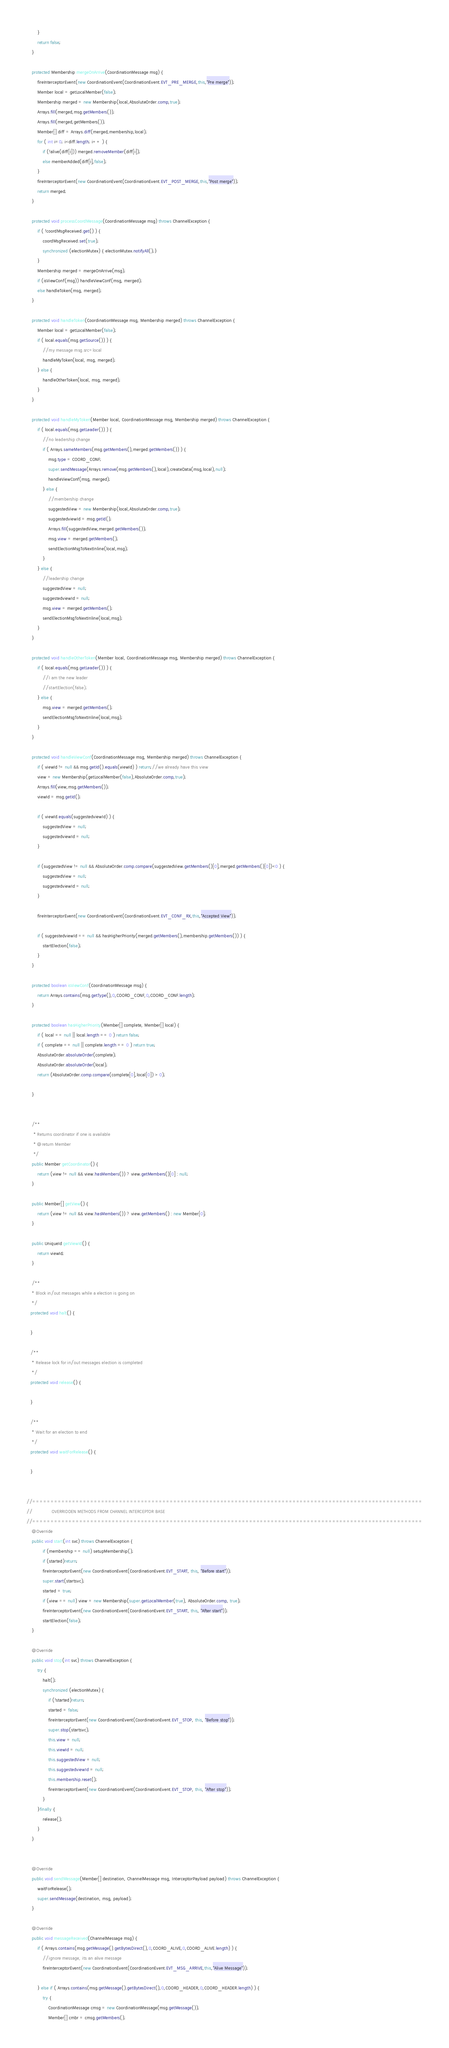<code> <loc_0><loc_0><loc_500><loc_500><_Java_>        }
        return false;
    }

    protected Membership mergeOnArrive(CoordinationMessage msg) {
        fireInterceptorEvent(new CoordinationEvent(CoordinationEvent.EVT_PRE_MERGE,this,"Pre merge"));
        Member local = getLocalMember(false);
        Membership merged = new Membership(local,AbsoluteOrder.comp,true);
        Arrays.fill(merged,msg.getMembers());
        Arrays.fill(merged,getMembers());
        Member[] diff = Arrays.diff(merged,membership,local);
        for ( int i=0; i<diff.length; i++ ) {
            if (!alive(diff[i])) merged.removeMember(diff[i]);
            else memberAdded(diff[i],false);
        }
        fireInterceptorEvent(new CoordinationEvent(CoordinationEvent.EVT_POST_MERGE,this,"Post merge"));
        return merged;
    }

    protected void processCoordMessage(CoordinationMessage msg) throws ChannelException {
        if ( !coordMsgReceived.get() ) {
            coordMsgReceived.set(true);
            synchronized (electionMutex) { electionMutex.notifyAll();}
        }
        Membership merged = mergeOnArrive(msg);
        if (isViewConf(msg)) handleViewConf(msg, merged);
        else handleToken(msg, merged);
    }

    protected void handleToken(CoordinationMessage msg, Membership merged) throws ChannelException {
        Member local = getLocalMember(false);
        if ( local.equals(msg.getSource()) ) {
            //my message msg.src=local
            handleMyToken(local, msg, merged);
        } else {
            handleOtherToken(local, msg, merged);
        }
    }

    protected void handleMyToken(Member local, CoordinationMessage msg, Membership merged) throws ChannelException {
        if ( local.equals(msg.getLeader()) ) {
            //no leadership change
            if ( Arrays.sameMembers(msg.getMembers(),merged.getMembers()) ) {
                msg.type = COORD_CONF;
                super.sendMessage(Arrays.remove(msg.getMembers(),local),createData(msg,local),null);
                handleViewConf(msg, merged);
            } else {
                //membership change
                suggestedView = new Membership(local,AbsoluteOrder.comp,true);
                suggestedviewId = msg.getId();
                Arrays.fill(suggestedView,merged.getMembers());
                msg.view = merged.getMembers();
                sendElectionMsgToNextInline(local,msg);
            }
        } else {
            //leadership change
            suggestedView = null;
            suggestedviewId = null;
            msg.view = merged.getMembers();
            sendElectionMsgToNextInline(local,msg);
        }
    }

    protected void handleOtherToken(Member local, CoordinationMessage msg, Membership merged) throws ChannelException {
        if ( local.equals(msg.getLeader()) ) {
            //I am the new leader
            //startElection(false);
        } else {
            msg.view = merged.getMembers();
            sendElectionMsgToNextInline(local,msg);
        }
    }

    protected void handleViewConf(CoordinationMessage msg, Membership merged) throws ChannelException {
        if ( viewId != null && msg.getId().equals(viewId) ) return;//we already have this view
        view = new Membership(getLocalMember(false),AbsoluteOrder.comp,true);
        Arrays.fill(view,msg.getMembers());
        viewId = msg.getId();

        if ( viewId.equals(suggestedviewId) ) {
            suggestedView = null;
            suggestedviewId = null;
        }

        if (suggestedView != null && AbsoluteOrder.comp.compare(suggestedView.getMembers()[0],merged.getMembers()[0])<0 ) {
            suggestedView = null;
            suggestedviewId = null;
        }

        fireInterceptorEvent(new CoordinationEvent(CoordinationEvent.EVT_CONF_RX,this,"Accepted View"));

        if ( suggestedviewId == null && hasHigherPriority(merged.getMembers(),membership.getMembers()) ) {
            startElection(false);
        }
    }

    protected boolean isViewConf(CoordinationMessage msg) {
        return Arrays.contains(msg.getType(),0,COORD_CONF,0,COORD_CONF.length);
    }

    protected boolean hasHigherPriority(Member[] complete, Member[] local) {
        if ( local == null || local.length == 0 ) return false;
        if ( complete == null || complete.length == 0 ) return true;
        AbsoluteOrder.absoluteOrder(complete);
        AbsoluteOrder.absoluteOrder(local);
        return (AbsoluteOrder.comp.compare(complete[0],local[0]) > 0);

    }


    /**
     * Returns coordinator if one is available
     * @return Member
     */
    public Member getCoordinator() {
        return (view != null && view.hasMembers()) ? view.getMembers()[0] : null;
    }

    public Member[] getView() {
        return (view != null && view.hasMembers()) ? view.getMembers() : new Member[0];
    }

    public UniqueId getViewId() {
        return viewId;
    }

    /**
    * Block in/out messages while a election is going on
    */
   protected void halt() {

   }

   /**
    * Release lock for in/out messages election is completed
    */
   protected void release() {

   }

   /**
    * Wait for an election to end
    */
   protected void waitForRelease() {

   }


//============================================================================================================
//              OVERRIDDEN METHODS FROM CHANNEL INTERCEPTOR BASE
//============================================================================================================
    @Override
    public void start(int svc) throws ChannelException {
            if (membership == null) setupMembership();
            if (started)return;
            fireInterceptorEvent(new CoordinationEvent(CoordinationEvent.EVT_START, this, "Before start"));
            super.start(startsvc);
            started = true;
            if (view == null) view = new Membership(super.getLocalMember(true), AbsoluteOrder.comp, true);
            fireInterceptorEvent(new CoordinationEvent(CoordinationEvent.EVT_START, this, "After start"));
            startElection(false);
    }

    @Override
    public void stop(int svc) throws ChannelException {
        try {
            halt();
            synchronized (electionMutex) {
                if (!started)return;
                started = false;
                fireInterceptorEvent(new CoordinationEvent(CoordinationEvent.EVT_STOP, this, "Before stop"));
                super.stop(startsvc);
                this.view = null;
                this.viewId = null;
                this.suggestedView = null;
                this.suggestedviewId = null;
                this.membership.reset();
                fireInterceptorEvent(new CoordinationEvent(CoordinationEvent.EVT_STOP, this, "After stop"));
            }
        }finally {
            release();
        }
    }


    @Override
    public void sendMessage(Member[] destination, ChannelMessage msg, InterceptorPayload payload) throws ChannelException {
        waitForRelease();
        super.sendMessage(destination, msg, payload);
    }

    @Override
    public void messageReceived(ChannelMessage msg) {
        if ( Arrays.contains(msg.getMessage().getBytesDirect(),0,COORD_ALIVE,0,COORD_ALIVE.length) ) {
            //ignore message, its an alive message
            fireInterceptorEvent(new CoordinationEvent(CoordinationEvent.EVT_MSG_ARRIVE,this,"Alive Message"));

        } else if ( Arrays.contains(msg.getMessage().getBytesDirect(),0,COORD_HEADER,0,COORD_HEADER.length) ) {
            try {
                CoordinationMessage cmsg = new CoordinationMessage(msg.getMessage());
                Member[] cmbr = cmsg.getMembers();</code> 